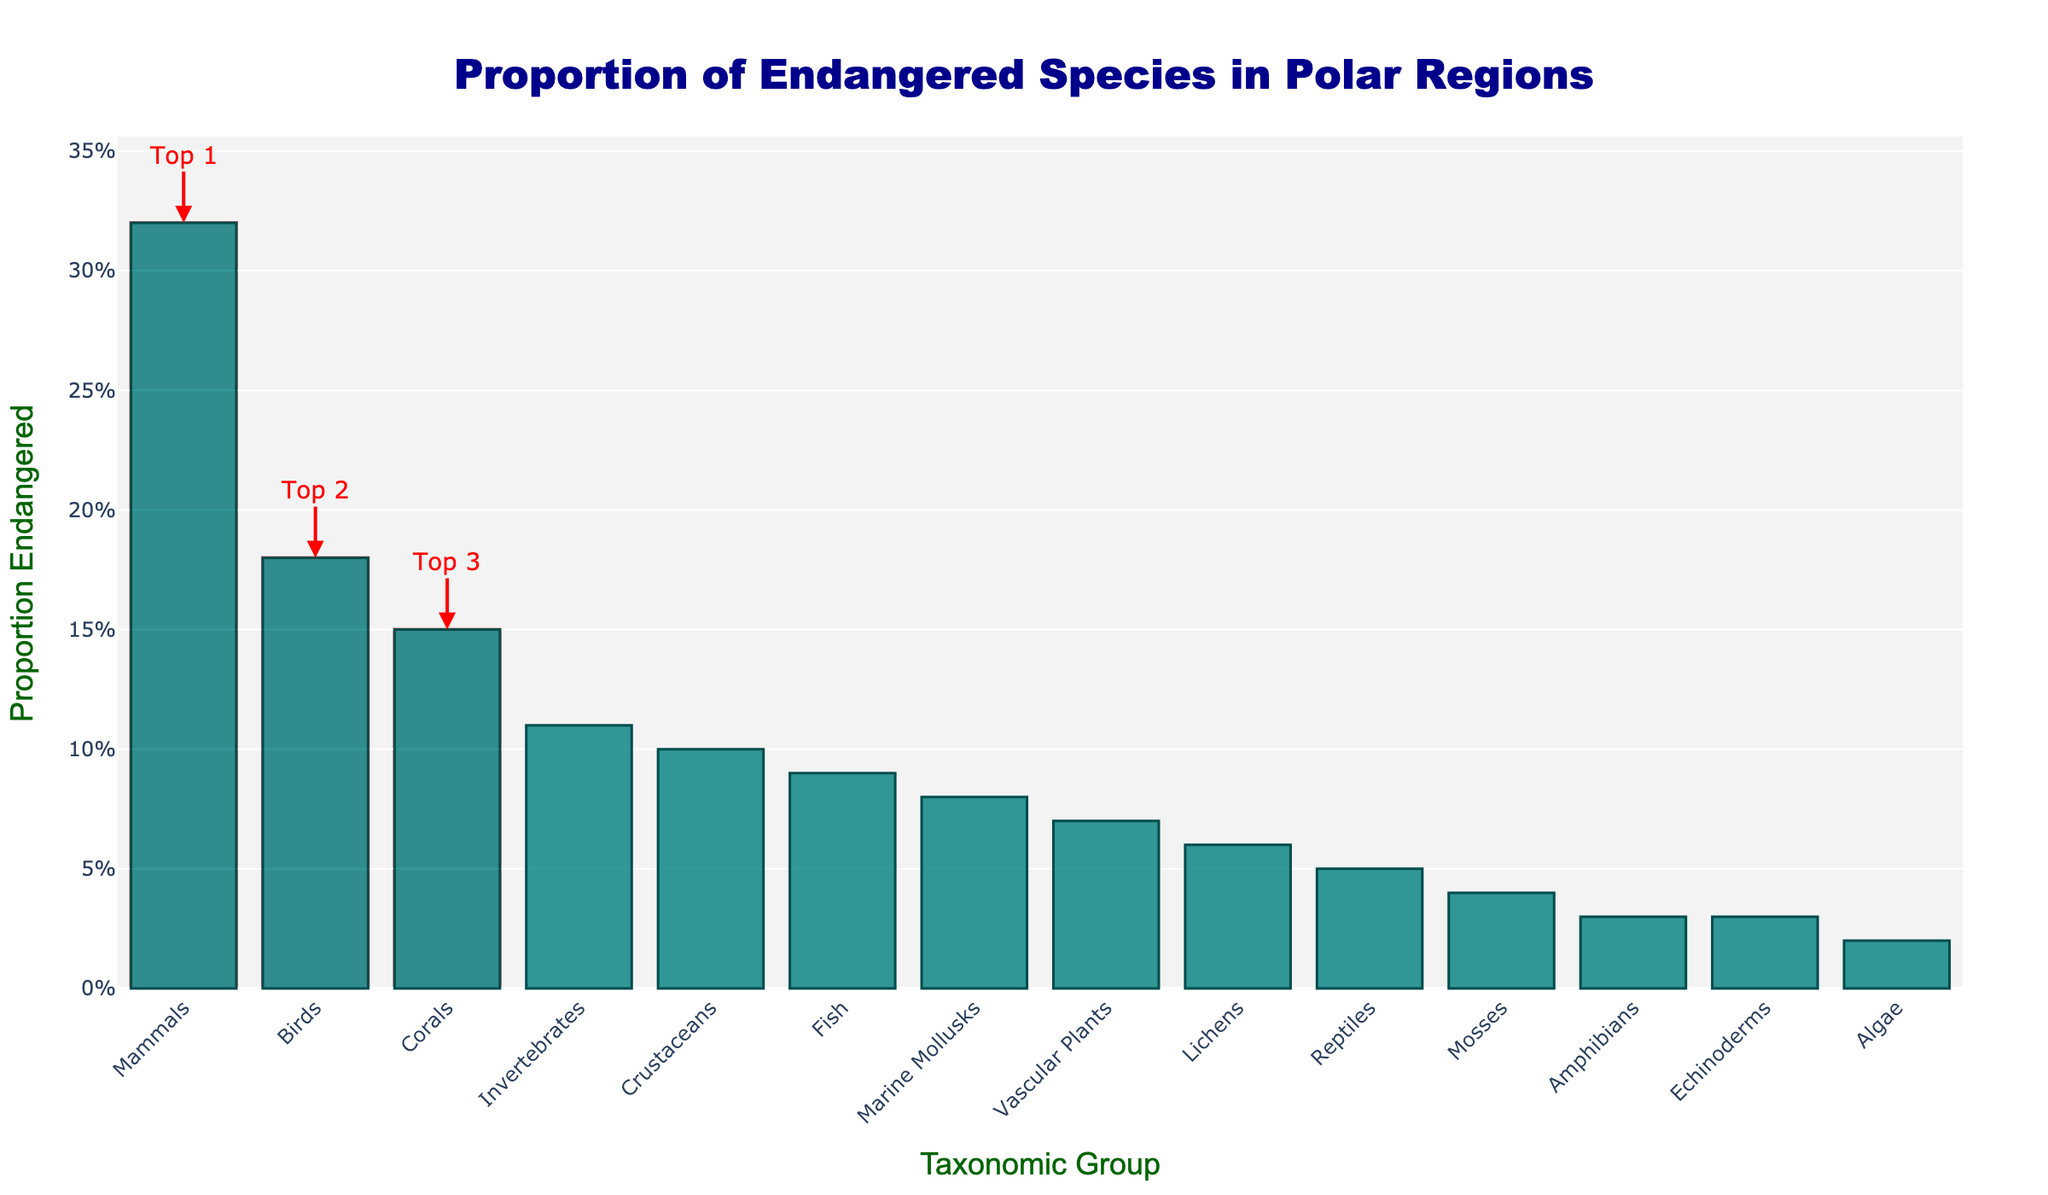What taxonomic group has the highest proportion of endangered species? Mammals have the tallest bar in the chart, indicating the highest proportion of endangered species.
Answer: Mammals Which group has a higher proportion of endangered species, Birds or Corals? The height of the bar for Corals is slightly lower than the bar for Birds, so Birds have a higher proportion of endangered species.
Answer: Birds What is the combined proportion of endangered species for Vascular Plants and Marine Mollusks? First, find the proportion of endangered species for Vascular Plants (0.07) and Marine Mollusks (0.08), then sum them: 0.07 + 0.08 = 0.15.
Answer: 0.15 How does the proportion of endangered Crustaceans compare to Lichens? The bar for Crustaceans is taller than the bar for Lichens, indicating a higher proportion of endangered species in Crustaceans.
Answer: Crustaceans have a higher proportion What is the difference in proportion of endangered species between Mammals and Amphibians? The proportion for Mammals is 0.32 and for Amphibians is 0.03. Subtract the two: 0.32 - 0.03 = 0.29.
Answer: 0.29 Which three taxonomic groups are highlighted as having the top three proportions of endangered species? The highlighted bars show that the top three groups are Mammals, Birds, and Corals.
Answer: Mammals, Birds, Corals What proportion of endangered species do Fish have compared to Invertebrates? The bar for Fish is lower than the bar for Invertebrates, indicating a smaller proportion of endangered species in Fish.
Answer: Fish have a smaller proportion What is the average proportion of endangered species for the top three highlighted groups? Sum the proportions of Mammals (0.32), Birds (0.18), and Corals (0.15), then divide by 3: (0.32 + 0.18 + 0.15) / 3 = 0.21.
Answer: 0.21 How does the visual highlight of the top three groups help in understanding the data? The highlighted sections and annotations draw attention to the groups with the highest proportions, making it easy to identify them at a glance.
Answer: It makes identification easier What does the annotation for the tallest bar represent? The annotation for the tallest bar, which corresponds to Mammals, indicates that Mammals are the top 1 group with the highest proportion of endangered species.
Answer: Mammals are the top 1 group 